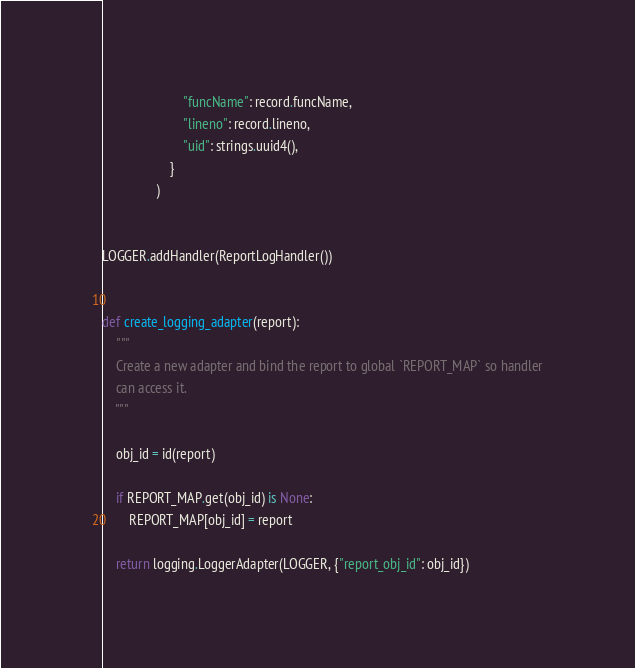Convert code to text. <code><loc_0><loc_0><loc_500><loc_500><_Python_>                        "funcName": record.funcName,
                        "lineno": record.lineno,
                        "uid": strings.uuid4(),
                    }
                )


LOGGER.addHandler(ReportLogHandler())


def create_logging_adapter(report):
    """
    Create a new adapter and bind the report to global `REPORT_MAP` so handler
    can access it.
    """

    obj_id = id(report)

    if REPORT_MAP.get(obj_id) is None:
        REPORT_MAP[obj_id] = report

    return logging.LoggerAdapter(LOGGER, {"report_obj_id": obj_id})
</code> 